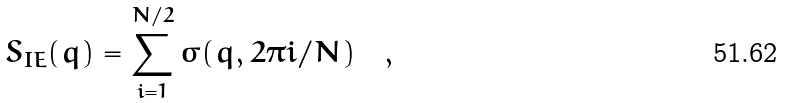<formula> <loc_0><loc_0><loc_500><loc_500>S _ { I E } ( q ) = \sum _ { i = 1 } ^ { N / 2 } \sigma ( q , 2 \pi i / N ) \quad ,</formula> 